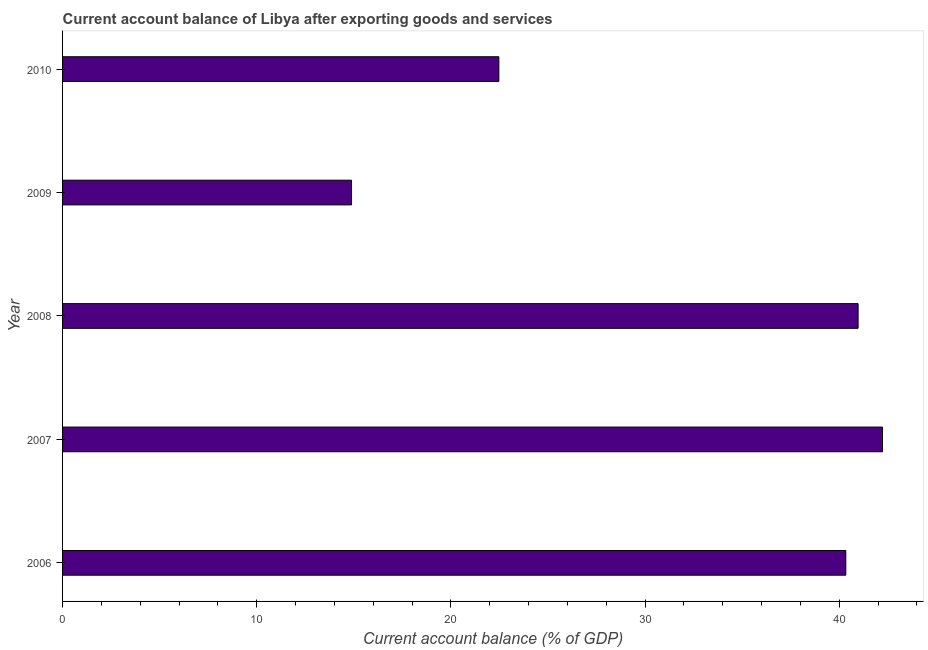Does the graph contain any zero values?
Your answer should be compact. No. What is the title of the graph?
Offer a very short reply. Current account balance of Libya after exporting goods and services. What is the label or title of the X-axis?
Offer a terse response. Current account balance (% of GDP). What is the current account balance in 2010?
Ensure brevity in your answer.  22.47. Across all years, what is the maximum current account balance?
Ensure brevity in your answer.  42.23. Across all years, what is the minimum current account balance?
Ensure brevity in your answer.  14.88. In which year was the current account balance minimum?
Your answer should be compact. 2009. What is the sum of the current account balance?
Your response must be concise. 160.89. What is the difference between the current account balance in 2007 and 2008?
Provide a succinct answer. 1.26. What is the average current account balance per year?
Your answer should be compact. 32.18. What is the median current account balance?
Give a very brief answer. 40.34. What is the ratio of the current account balance in 2008 to that in 2009?
Your answer should be compact. 2.75. Is the current account balance in 2007 less than that in 2010?
Offer a terse response. No. What is the difference between the highest and the second highest current account balance?
Provide a succinct answer. 1.26. What is the difference between the highest and the lowest current account balance?
Offer a very short reply. 27.34. How many bars are there?
Provide a succinct answer. 5. Are all the bars in the graph horizontal?
Offer a very short reply. Yes. How many years are there in the graph?
Keep it short and to the point. 5. Are the values on the major ticks of X-axis written in scientific E-notation?
Your answer should be compact. No. What is the Current account balance (% of GDP) of 2006?
Your response must be concise. 40.34. What is the Current account balance (% of GDP) of 2007?
Keep it short and to the point. 42.23. What is the Current account balance (% of GDP) in 2008?
Ensure brevity in your answer.  40.97. What is the Current account balance (% of GDP) in 2009?
Offer a terse response. 14.88. What is the Current account balance (% of GDP) of 2010?
Your response must be concise. 22.47. What is the difference between the Current account balance (% of GDP) in 2006 and 2007?
Your response must be concise. -1.89. What is the difference between the Current account balance (% of GDP) in 2006 and 2008?
Ensure brevity in your answer.  -0.63. What is the difference between the Current account balance (% of GDP) in 2006 and 2009?
Make the answer very short. 25.45. What is the difference between the Current account balance (% of GDP) in 2006 and 2010?
Your answer should be compact. 17.87. What is the difference between the Current account balance (% of GDP) in 2007 and 2008?
Your answer should be compact. 1.26. What is the difference between the Current account balance (% of GDP) in 2007 and 2009?
Give a very brief answer. 27.34. What is the difference between the Current account balance (% of GDP) in 2007 and 2010?
Your answer should be very brief. 19.76. What is the difference between the Current account balance (% of GDP) in 2008 and 2009?
Ensure brevity in your answer.  26.09. What is the difference between the Current account balance (% of GDP) in 2008 and 2010?
Your answer should be very brief. 18.5. What is the difference between the Current account balance (% of GDP) in 2009 and 2010?
Provide a succinct answer. -7.59. What is the ratio of the Current account balance (% of GDP) in 2006 to that in 2007?
Offer a very short reply. 0.95. What is the ratio of the Current account balance (% of GDP) in 2006 to that in 2009?
Give a very brief answer. 2.71. What is the ratio of the Current account balance (% of GDP) in 2006 to that in 2010?
Offer a terse response. 1.79. What is the ratio of the Current account balance (% of GDP) in 2007 to that in 2008?
Give a very brief answer. 1.03. What is the ratio of the Current account balance (% of GDP) in 2007 to that in 2009?
Offer a very short reply. 2.84. What is the ratio of the Current account balance (% of GDP) in 2007 to that in 2010?
Your answer should be compact. 1.88. What is the ratio of the Current account balance (% of GDP) in 2008 to that in 2009?
Keep it short and to the point. 2.75. What is the ratio of the Current account balance (% of GDP) in 2008 to that in 2010?
Your answer should be compact. 1.82. What is the ratio of the Current account balance (% of GDP) in 2009 to that in 2010?
Provide a succinct answer. 0.66. 